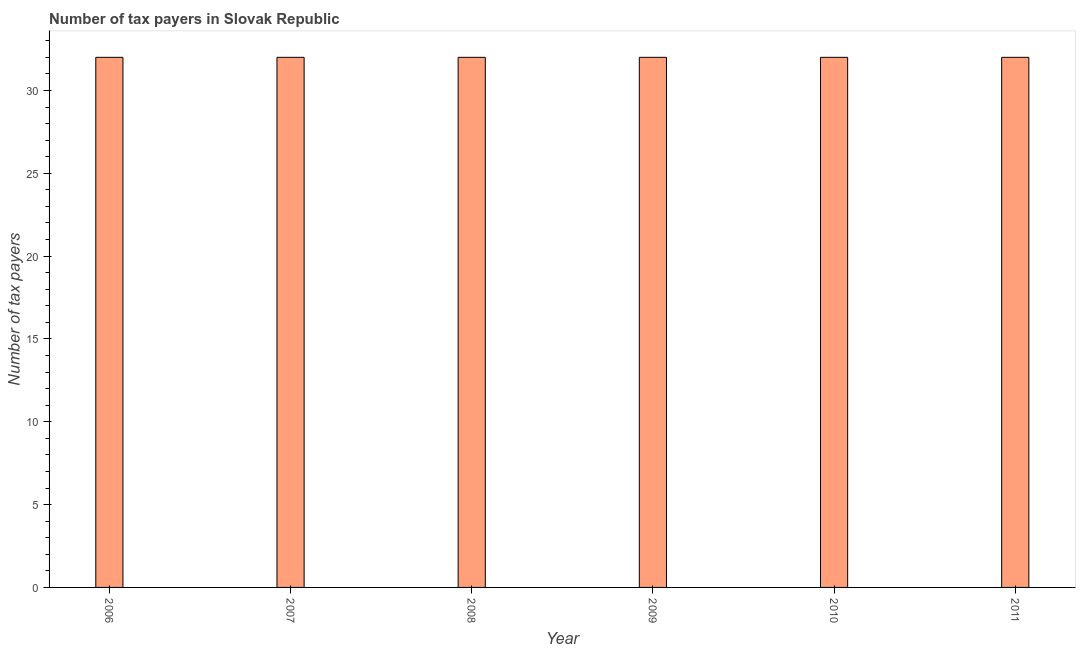Does the graph contain grids?
Provide a succinct answer. No. What is the title of the graph?
Provide a succinct answer. Number of tax payers in Slovak Republic. What is the label or title of the X-axis?
Your answer should be very brief. Year. What is the label or title of the Y-axis?
Your answer should be very brief. Number of tax payers. Across all years, what is the minimum number of tax payers?
Offer a very short reply. 32. In which year was the number of tax payers maximum?
Keep it short and to the point. 2006. What is the sum of the number of tax payers?
Ensure brevity in your answer.  192. What is the difference between the number of tax payers in 2008 and 2011?
Your answer should be very brief. 0. What is the median number of tax payers?
Provide a short and direct response. 32. In how many years, is the number of tax payers greater than 22 ?
Keep it short and to the point. 6. Is the sum of the number of tax payers in 2006 and 2009 greater than the maximum number of tax payers across all years?
Your response must be concise. Yes. In how many years, is the number of tax payers greater than the average number of tax payers taken over all years?
Offer a terse response. 0. Are all the bars in the graph horizontal?
Provide a short and direct response. No. How many years are there in the graph?
Give a very brief answer. 6. What is the Number of tax payers in 2006?
Provide a succinct answer. 32. What is the Number of tax payers of 2007?
Ensure brevity in your answer.  32. What is the Number of tax payers in 2008?
Make the answer very short. 32. What is the Number of tax payers of 2011?
Your answer should be very brief. 32. What is the difference between the Number of tax payers in 2006 and 2007?
Provide a succinct answer. 0. What is the difference between the Number of tax payers in 2006 and 2008?
Your answer should be compact. 0. What is the difference between the Number of tax payers in 2006 and 2010?
Offer a terse response. 0. What is the difference between the Number of tax payers in 2006 and 2011?
Ensure brevity in your answer.  0. What is the difference between the Number of tax payers in 2007 and 2009?
Your answer should be compact. 0. What is the difference between the Number of tax payers in 2007 and 2010?
Keep it short and to the point. 0. What is the difference between the Number of tax payers in 2008 and 2009?
Your response must be concise. 0. What is the difference between the Number of tax payers in 2008 and 2010?
Keep it short and to the point. 0. What is the difference between the Number of tax payers in 2008 and 2011?
Your answer should be very brief. 0. What is the difference between the Number of tax payers in 2010 and 2011?
Keep it short and to the point. 0. What is the ratio of the Number of tax payers in 2006 to that in 2007?
Give a very brief answer. 1. What is the ratio of the Number of tax payers in 2006 to that in 2008?
Offer a very short reply. 1. What is the ratio of the Number of tax payers in 2006 to that in 2009?
Keep it short and to the point. 1. What is the ratio of the Number of tax payers in 2007 to that in 2011?
Your response must be concise. 1. What is the ratio of the Number of tax payers in 2008 to that in 2011?
Your answer should be very brief. 1. What is the ratio of the Number of tax payers in 2010 to that in 2011?
Your response must be concise. 1. 